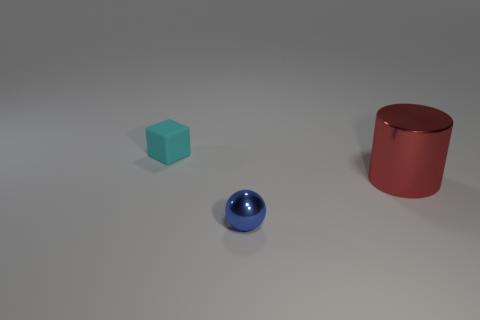Add 3 tiny shiny objects. How many objects exist? 6 Subtract all cubes. How many objects are left? 2 Subtract all big gray matte spheres. Subtract all balls. How many objects are left? 2 Add 3 blue metallic objects. How many blue metallic objects are left? 4 Add 1 large green balls. How many large green balls exist? 1 Subtract 0 yellow blocks. How many objects are left? 3 